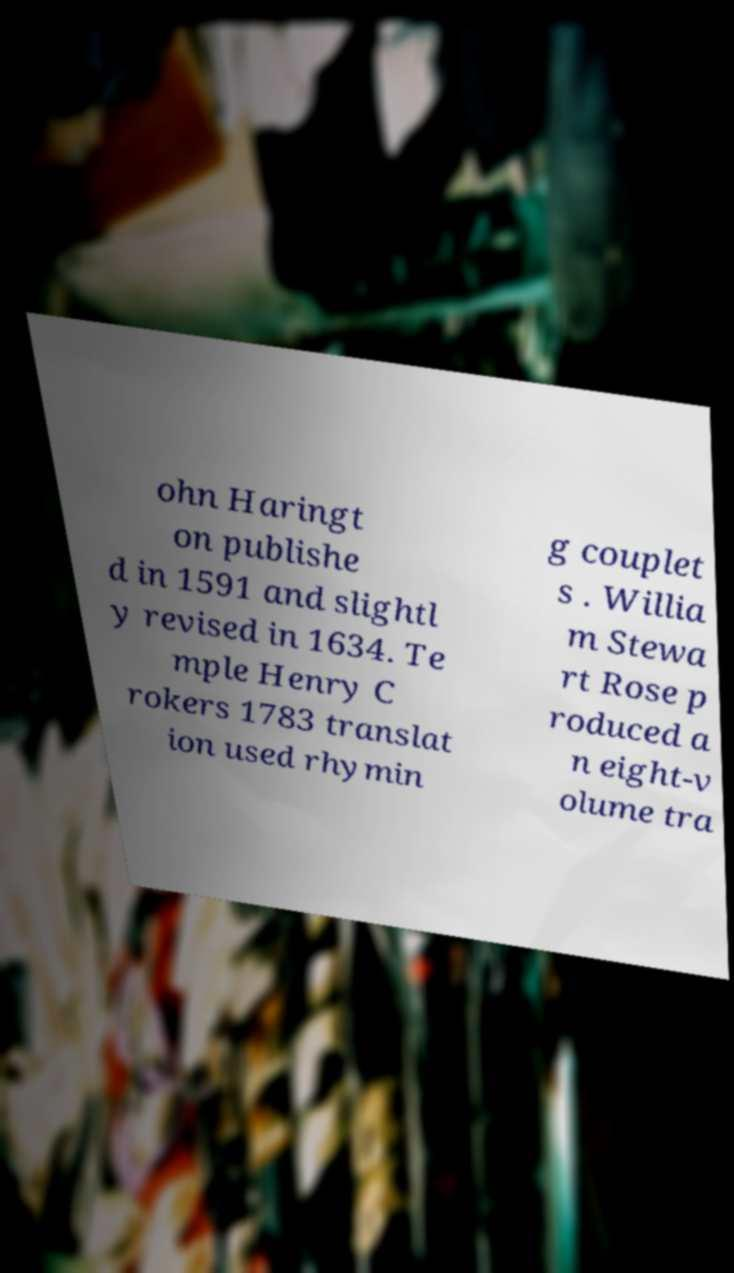Could you assist in decoding the text presented in this image and type it out clearly? ohn Haringt on publishe d in 1591 and slightl y revised in 1634. Te mple Henry C rokers 1783 translat ion used rhymin g couplet s . Willia m Stewa rt Rose p roduced a n eight-v olume tra 